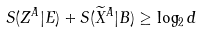Convert formula to latex. <formula><loc_0><loc_0><loc_500><loc_500>S ( { Z } ^ { A } | E ) + S ( \widetilde { X } ^ { A } | B ) \geq \log _ { 2 } d</formula> 